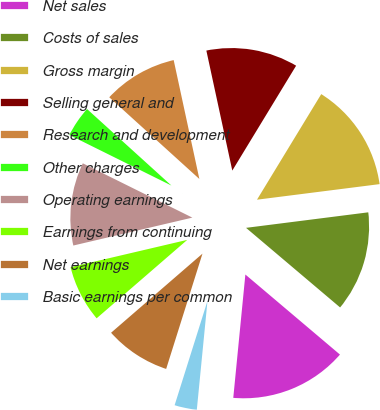Convert chart to OTSL. <chart><loc_0><loc_0><loc_500><loc_500><pie_chart><fcel>Net sales<fcel>Costs of sales<fcel>Gross margin<fcel>Selling general and<fcel>Research and development<fcel>Other charges<fcel>Operating earnings<fcel>Earnings from continuing<fcel>Net earnings<fcel>Basic earnings per common<nl><fcel>15.38%<fcel>13.19%<fcel>14.29%<fcel>12.09%<fcel>9.89%<fcel>4.4%<fcel>10.99%<fcel>7.69%<fcel>8.79%<fcel>3.3%<nl></chart> 